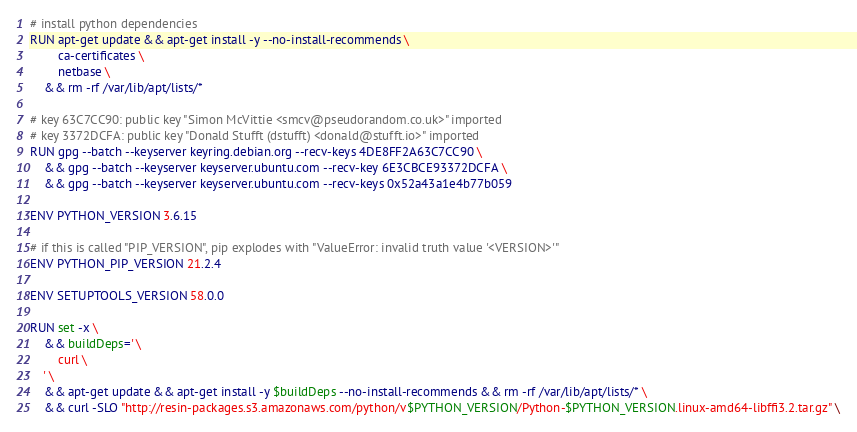Convert code to text. <code><loc_0><loc_0><loc_500><loc_500><_Dockerfile_>
# install python dependencies
RUN apt-get update && apt-get install -y --no-install-recommends \
		ca-certificates \
		netbase \
	&& rm -rf /var/lib/apt/lists/*

# key 63C7CC90: public key "Simon McVittie <smcv@pseudorandom.co.uk>" imported
# key 3372DCFA: public key "Donald Stufft (dstufft) <donald@stufft.io>" imported
RUN gpg --batch --keyserver keyring.debian.org --recv-keys 4DE8FF2A63C7CC90 \
	&& gpg --batch --keyserver keyserver.ubuntu.com --recv-key 6E3CBCE93372DCFA \
	&& gpg --batch --keyserver keyserver.ubuntu.com --recv-keys 0x52a43a1e4b77b059

ENV PYTHON_VERSION 3.6.15

# if this is called "PIP_VERSION", pip explodes with "ValueError: invalid truth value '<VERSION>'"
ENV PYTHON_PIP_VERSION 21.2.4

ENV SETUPTOOLS_VERSION 58.0.0

RUN set -x \
	&& buildDeps=' \
		curl \
	' \
	&& apt-get update && apt-get install -y $buildDeps --no-install-recommends && rm -rf /var/lib/apt/lists/* \
	&& curl -SLO "http://resin-packages.s3.amazonaws.com/python/v$PYTHON_VERSION/Python-$PYTHON_VERSION.linux-amd64-libffi3.2.tar.gz" \</code> 